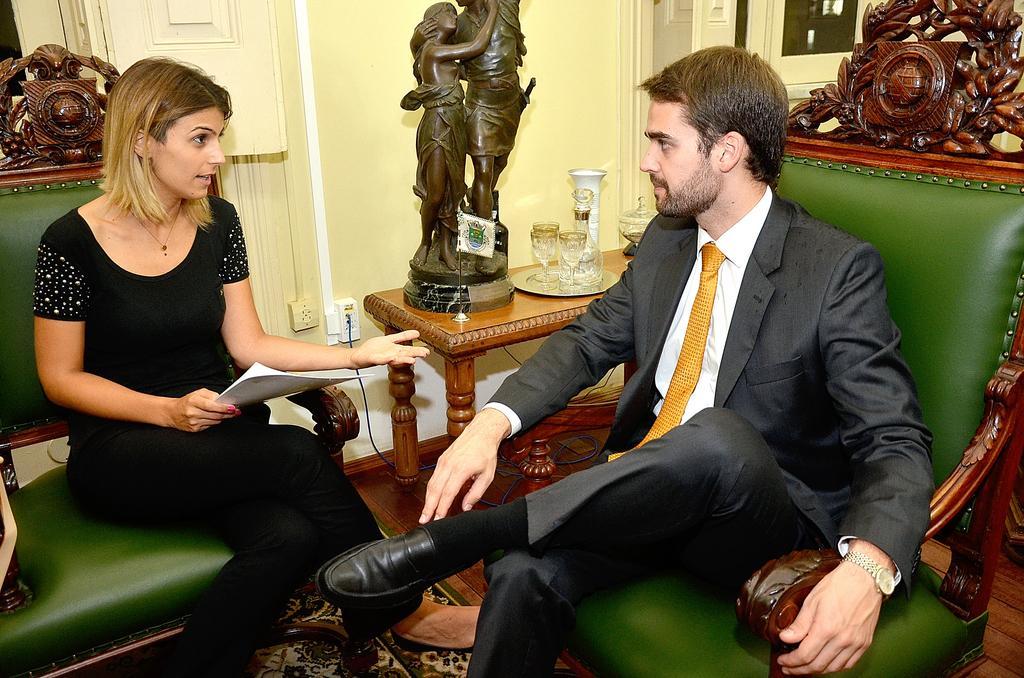Describe this image in one or two sentences. In this image we can see two people are sitting on the sofa, one is holding a paper. Beside them there is a table. On the table there is a statue, glasses and some other objects. In the Background there is a wall. 